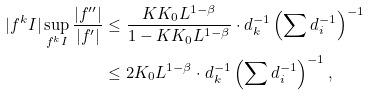<formula> <loc_0><loc_0><loc_500><loc_500>| f ^ { k } I | \sup _ { f ^ { k } I } \frac { | f ^ { \prime \prime } | } { | f ^ { \prime } | } & \leq \frac { K K _ { 0 } L ^ { 1 - \beta } } { 1 - K K _ { 0 } L ^ { 1 - \beta } } \cdot d _ { k } ^ { - 1 } \left ( \sum d _ { i } ^ { - 1 } \right ) ^ { - 1 } \\ & \leq 2 K _ { 0 } L ^ { 1 - \beta } \cdot d _ { k } ^ { - 1 } \left ( \sum d _ { i } ^ { - 1 } \right ) ^ { - 1 } ,</formula> 